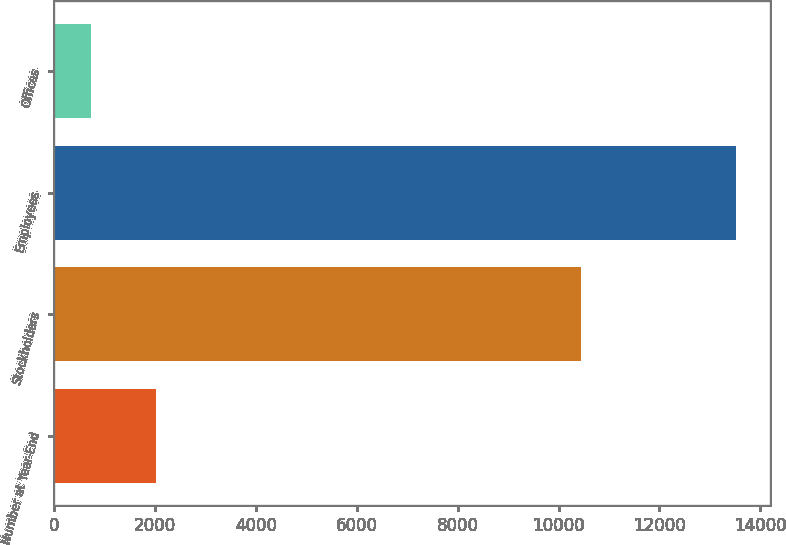Convert chart to OTSL. <chart><loc_0><loc_0><loc_500><loc_500><bar_chart><fcel>Number at Year-End<fcel>Stockholders<fcel>Employees<fcel>Offices<nl><fcel>2005<fcel>10437<fcel>13525<fcel>724<nl></chart> 